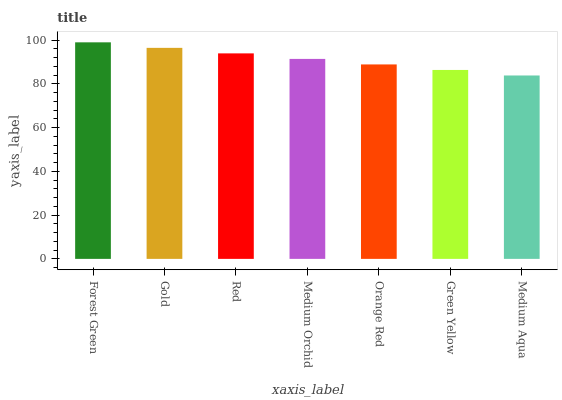Is Medium Aqua the minimum?
Answer yes or no. Yes. Is Forest Green the maximum?
Answer yes or no. Yes. Is Gold the minimum?
Answer yes or no. No. Is Gold the maximum?
Answer yes or no. No. Is Forest Green greater than Gold?
Answer yes or no. Yes. Is Gold less than Forest Green?
Answer yes or no. Yes. Is Gold greater than Forest Green?
Answer yes or no. No. Is Forest Green less than Gold?
Answer yes or no. No. Is Medium Orchid the high median?
Answer yes or no. Yes. Is Medium Orchid the low median?
Answer yes or no. Yes. Is Medium Aqua the high median?
Answer yes or no. No. Is Medium Aqua the low median?
Answer yes or no. No. 